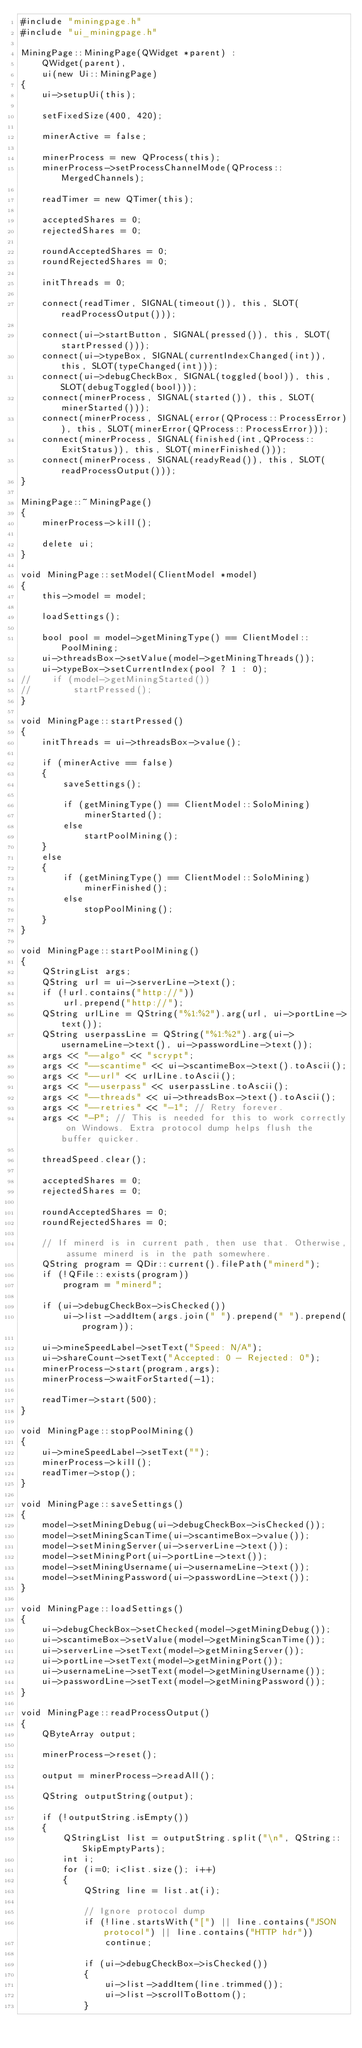<code> <loc_0><loc_0><loc_500><loc_500><_C++_>#include "miningpage.h"
#include "ui_miningpage.h"

MiningPage::MiningPage(QWidget *parent) :
    QWidget(parent),
    ui(new Ui::MiningPage)
{
    ui->setupUi(this);

    setFixedSize(400, 420);

    minerActive = false;

    minerProcess = new QProcess(this);
    minerProcess->setProcessChannelMode(QProcess::MergedChannels);

    readTimer = new QTimer(this);

    acceptedShares = 0;
    rejectedShares = 0;

    roundAcceptedShares = 0;
    roundRejectedShares = 0;

    initThreads = 0;

    connect(readTimer, SIGNAL(timeout()), this, SLOT(readProcessOutput()));

    connect(ui->startButton, SIGNAL(pressed()), this, SLOT(startPressed()));
    connect(ui->typeBox, SIGNAL(currentIndexChanged(int)), this, SLOT(typeChanged(int)));
    connect(ui->debugCheckBox, SIGNAL(toggled(bool)), this, SLOT(debugToggled(bool)));
    connect(minerProcess, SIGNAL(started()), this, SLOT(minerStarted()));
    connect(minerProcess, SIGNAL(error(QProcess::ProcessError)), this, SLOT(minerError(QProcess::ProcessError)));
    connect(minerProcess, SIGNAL(finished(int,QProcess::ExitStatus)), this, SLOT(minerFinished()));
    connect(minerProcess, SIGNAL(readyRead()), this, SLOT(readProcessOutput()));
}

MiningPage::~MiningPage()
{
    minerProcess->kill();

    delete ui;
}

void MiningPage::setModel(ClientModel *model)
{
    this->model = model;

    loadSettings();

    bool pool = model->getMiningType() == ClientModel::PoolMining;
    ui->threadsBox->setValue(model->getMiningThreads());
    ui->typeBox->setCurrentIndex(pool ? 1 : 0);
//    if (model->getMiningStarted())
//        startPressed();
}

void MiningPage::startPressed()
{
    initThreads = ui->threadsBox->value();

    if (minerActive == false)
    {
        saveSettings();

        if (getMiningType() == ClientModel::SoloMining)
            minerStarted();
        else
            startPoolMining();
    }
    else
    {
        if (getMiningType() == ClientModel::SoloMining)
            minerFinished();
        else
            stopPoolMining();
    }
}

void MiningPage::startPoolMining()
{
    QStringList args;
    QString url = ui->serverLine->text();
    if (!url.contains("http://"))
        url.prepend("http://");
    QString urlLine = QString("%1:%2").arg(url, ui->portLine->text());
    QString userpassLine = QString("%1:%2").arg(ui->usernameLine->text(), ui->passwordLine->text());
    args << "--algo" << "scrypt";
    args << "--scantime" << ui->scantimeBox->text().toAscii();
    args << "--url" << urlLine.toAscii();
    args << "--userpass" << userpassLine.toAscii();
    args << "--threads" << ui->threadsBox->text().toAscii();
    args << "--retries" << "-1"; // Retry forever.
    args << "-P"; // This is needed for this to work correctly on Windows. Extra protocol dump helps flush the buffer quicker.

    threadSpeed.clear();

    acceptedShares = 0;
    rejectedShares = 0;

    roundAcceptedShares = 0;
    roundRejectedShares = 0;

    // If minerd is in current path, then use that. Otherwise, assume minerd is in the path somewhere.
    QString program = QDir::current().filePath("minerd");
    if (!QFile::exists(program))
        program = "minerd";

    if (ui->debugCheckBox->isChecked())
        ui->list->addItem(args.join(" ").prepend(" ").prepend(program));

    ui->mineSpeedLabel->setText("Speed: N/A");
    ui->shareCount->setText("Accepted: 0 - Rejected: 0");
    minerProcess->start(program,args);
    minerProcess->waitForStarted(-1);

    readTimer->start(500);
}

void MiningPage::stopPoolMining()
{
    ui->mineSpeedLabel->setText("");
    minerProcess->kill();
    readTimer->stop();
}

void MiningPage::saveSettings()
{
    model->setMiningDebug(ui->debugCheckBox->isChecked());
    model->setMiningScanTime(ui->scantimeBox->value());
    model->setMiningServer(ui->serverLine->text());
    model->setMiningPort(ui->portLine->text());
    model->setMiningUsername(ui->usernameLine->text());
    model->setMiningPassword(ui->passwordLine->text());
}

void MiningPage::loadSettings()
{
    ui->debugCheckBox->setChecked(model->getMiningDebug());
    ui->scantimeBox->setValue(model->getMiningScanTime());
    ui->serverLine->setText(model->getMiningServer());
    ui->portLine->setText(model->getMiningPort());
    ui->usernameLine->setText(model->getMiningUsername());
    ui->passwordLine->setText(model->getMiningPassword());
}

void MiningPage::readProcessOutput()
{
    QByteArray output;

    minerProcess->reset();

    output = minerProcess->readAll();

    QString outputString(output);

    if (!outputString.isEmpty())
    {
        QStringList list = outputString.split("\n", QString::SkipEmptyParts);
        int i;
        for (i=0; i<list.size(); i++)
        {
            QString line = list.at(i);

            // Ignore protocol dump
            if (!line.startsWith("[") || line.contains("JSON protocol") || line.contains("HTTP hdr"))
                continue;

            if (ui->debugCheckBox->isChecked())
            {
                ui->list->addItem(line.trimmed());
                ui->list->scrollToBottom();
            }
</code> 